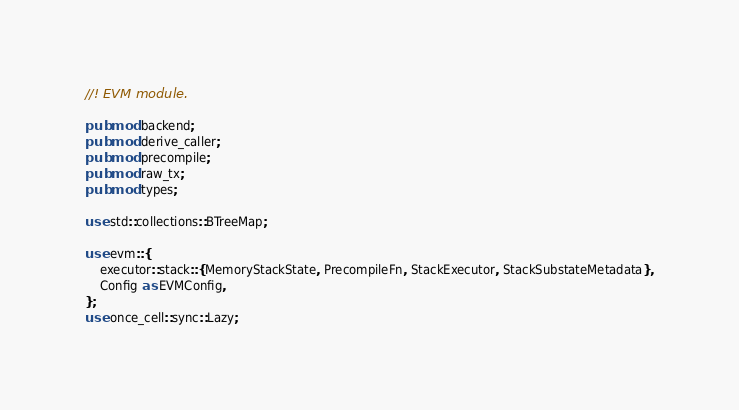Convert code to text. <code><loc_0><loc_0><loc_500><loc_500><_Rust_>//! EVM module.

pub mod backend;
pub mod derive_caller;
pub mod precompile;
pub mod raw_tx;
pub mod types;

use std::collections::BTreeMap;

use evm::{
    executor::stack::{MemoryStackState, PrecompileFn, StackExecutor, StackSubstateMetadata},
    Config as EVMConfig,
};
use once_cell::sync::Lazy;</code> 